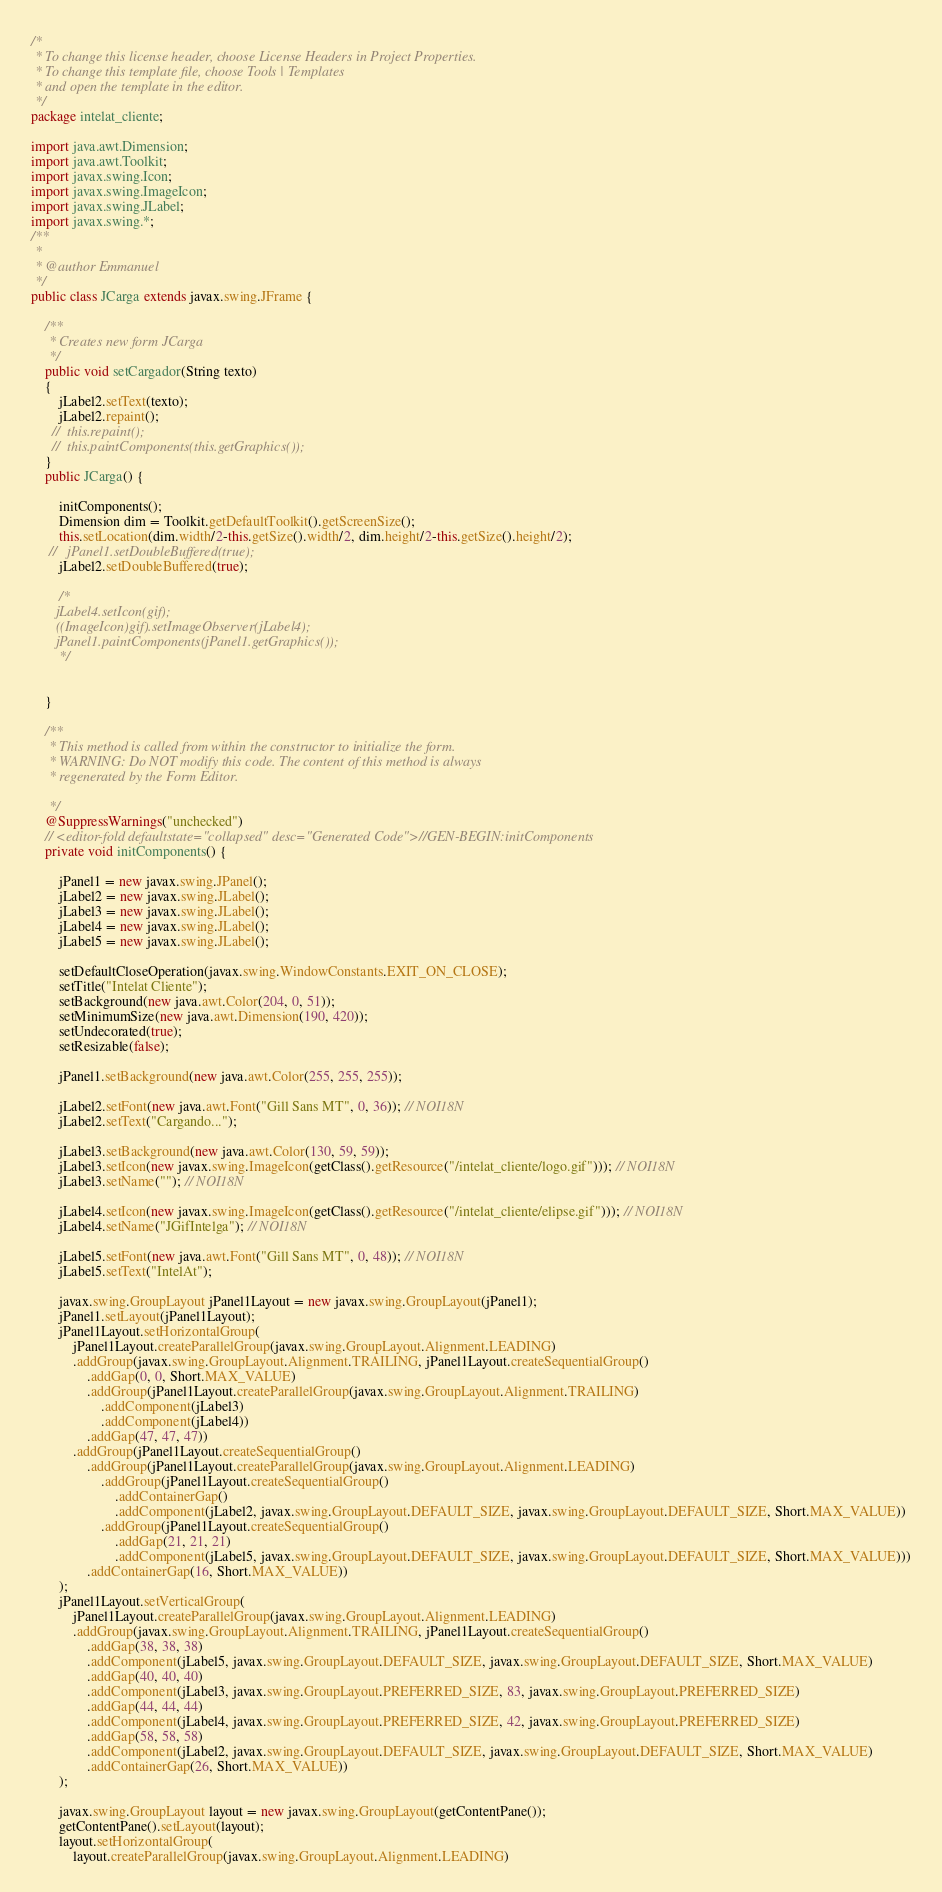Convert code to text. <code><loc_0><loc_0><loc_500><loc_500><_Java_>/*
 * To change this license header, choose License Headers in Project Properties.
 * To change this template file, choose Tools | Templates
 * and open the template in the editor.
 */
package intelat_cliente;

import java.awt.Dimension;
import java.awt.Toolkit;
import javax.swing.Icon;
import javax.swing.ImageIcon;
import javax.swing.JLabel;
import javax.swing.*;
/**
 *
 * @author Emmanuel
 */
public class JCarga extends javax.swing.JFrame {

    /**
     * Creates new form JCarga
     */
    public void setCargador(String texto)
    {
        jLabel2.setText(texto);
        jLabel2.repaint();
      //  this.repaint();
      //  this.paintComponents(this.getGraphics());
    }
    public JCarga() {
       
        initComponents();
        Dimension dim = Toolkit.getDefaultToolkit().getScreenSize();
        this.setLocation(dim.width/2-this.getSize().width/2, dim.height/2-this.getSize().height/2);
     //   jPanel1.setDoubleBuffered(true);
        jLabel2.setDoubleBuffered(true);
        
        /*
       jLabel4.setIcon(gif);
       ((ImageIcon)gif).setImageObserver(jLabel4);
       jPanel1.paintComponents(jPanel1.getGraphics());
        */
       
         
    }

    /**
     * This method is called from within the constructor to initialize the form.
     * WARNING: Do NOT modify this code. The content of this method is always
     * regenerated by the Form Editor.
        
     */
    @SuppressWarnings("unchecked")
    // <editor-fold defaultstate="collapsed" desc="Generated Code">//GEN-BEGIN:initComponents
    private void initComponents() {

        jPanel1 = new javax.swing.JPanel();
        jLabel2 = new javax.swing.JLabel();
        jLabel3 = new javax.swing.JLabel();
        jLabel4 = new javax.swing.JLabel();
        jLabel5 = new javax.swing.JLabel();

        setDefaultCloseOperation(javax.swing.WindowConstants.EXIT_ON_CLOSE);
        setTitle("Intelat Cliente");
        setBackground(new java.awt.Color(204, 0, 51));
        setMinimumSize(new java.awt.Dimension(190, 420));
        setUndecorated(true);
        setResizable(false);

        jPanel1.setBackground(new java.awt.Color(255, 255, 255));

        jLabel2.setFont(new java.awt.Font("Gill Sans MT", 0, 36)); // NOI18N
        jLabel2.setText("Cargando...");

        jLabel3.setBackground(new java.awt.Color(130, 59, 59));
        jLabel3.setIcon(new javax.swing.ImageIcon(getClass().getResource("/intelat_cliente/logo.gif"))); // NOI18N
        jLabel3.setName(""); // NOI18N

        jLabel4.setIcon(new javax.swing.ImageIcon(getClass().getResource("/intelat_cliente/elipse.gif"))); // NOI18N
        jLabel4.setName("JGifIntelga"); // NOI18N

        jLabel5.setFont(new java.awt.Font("Gill Sans MT", 0, 48)); // NOI18N
        jLabel5.setText("IntelAt");

        javax.swing.GroupLayout jPanel1Layout = new javax.swing.GroupLayout(jPanel1);
        jPanel1.setLayout(jPanel1Layout);
        jPanel1Layout.setHorizontalGroup(
            jPanel1Layout.createParallelGroup(javax.swing.GroupLayout.Alignment.LEADING)
            .addGroup(javax.swing.GroupLayout.Alignment.TRAILING, jPanel1Layout.createSequentialGroup()
                .addGap(0, 0, Short.MAX_VALUE)
                .addGroup(jPanel1Layout.createParallelGroup(javax.swing.GroupLayout.Alignment.TRAILING)
                    .addComponent(jLabel3)
                    .addComponent(jLabel4))
                .addGap(47, 47, 47))
            .addGroup(jPanel1Layout.createSequentialGroup()
                .addGroup(jPanel1Layout.createParallelGroup(javax.swing.GroupLayout.Alignment.LEADING)
                    .addGroup(jPanel1Layout.createSequentialGroup()
                        .addContainerGap()
                        .addComponent(jLabel2, javax.swing.GroupLayout.DEFAULT_SIZE, javax.swing.GroupLayout.DEFAULT_SIZE, Short.MAX_VALUE))
                    .addGroup(jPanel1Layout.createSequentialGroup()
                        .addGap(21, 21, 21)
                        .addComponent(jLabel5, javax.swing.GroupLayout.DEFAULT_SIZE, javax.swing.GroupLayout.DEFAULT_SIZE, Short.MAX_VALUE)))
                .addContainerGap(16, Short.MAX_VALUE))
        );
        jPanel1Layout.setVerticalGroup(
            jPanel1Layout.createParallelGroup(javax.swing.GroupLayout.Alignment.LEADING)
            .addGroup(javax.swing.GroupLayout.Alignment.TRAILING, jPanel1Layout.createSequentialGroup()
                .addGap(38, 38, 38)
                .addComponent(jLabel5, javax.swing.GroupLayout.DEFAULT_SIZE, javax.swing.GroupLayout.DEFAULT_SIZE, Short.MAX_VALUE)
                .addGap(40, 40, 40)
                .addComponent(jLabel3, javax.swing.GroupLayout.PREFERRED_SIZE, 83, javax.swing.GroupLayout.PREFERRED_SIZE)
                .addGap(44, 44, 44)
                .addComponent(jLabel4, javax.swing.GroupLayout.PREFERRED_SIZE, 42, javax.swing.GroupLayout.PREFERRED_SIZE)
                .addGap(58, 58, 58)
                .addComponent(jLabel2, javax.swing.GroupLayout.DEFAULT_SIZE, javax.swing.GroupLayout.DEFAULT_SIZE, Short.MAX_VALUE)
                .addContainerGap(26, Short.MAX_VALUE))
        );

        javax.swing.GroupLayout layout = new javax.swing.GroupLayout(getContentPane());
        getContentPane().setLayout(layout);
        layout.setHorizontalGroup(
            layout.createParallelGroup(javax.swing.GroupLayout.Alignment.LEADING)</code> 